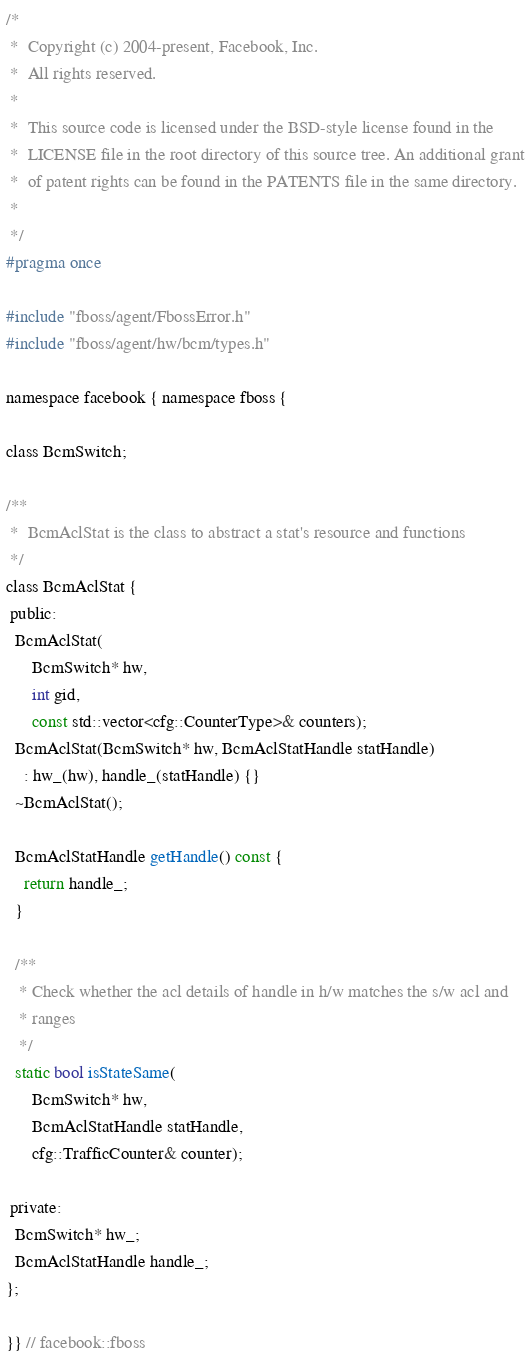<code> <loc_0><loc_0><loc_500><loc_500><_C_>/*
 *  Copyright (c) 2004-present, Facebook, Inc.
 *  All rights reserved.
 *
 *  This source code is licensed under the BSD-style license found in the
 *  LICENSE file in the root directory of this source tree. An additional grant
 *  of patent rights can be found in the PATENTS file in the same directory.
 *
 */
#pragma once

#include "fboss/agent/FbossError.h"
#include "fboss/agent/hw/bcm/types.h"

namespace facebook { namespace fboss {

class BcmSwitch;

/**
 *  BcmAclStat is the class to abstract a stat's resource and functions
 */
class BcmAclStat {
 public:
  BcmAclStat(
      BcmSwitch* hw,
      int gid,
      const std::vector<cfg::CounterType>& counters);
  BcmAclStat(BcmSwitch* hw, BcmAclStatHandle statHandle)
    : hw_(hw), handle_(statHandle) {}
  ~BcmAclStat();

  BcmAclStatHandle getHandle() const {
    return handle_;
  }

  /**
   * Check whether the acl details of handle in h/w matches the s/w acl and
   * ranges
   */
  static bool isStateSame(
      BcmSwitch* hw,
      BcmAclStatHandle statHandle,
      cfg::TrafficCounter& counter);

 private:
  BcmSwitch* hw_;
  BcmAclStatHandle handle_;
};

}} // facebook::fboss
</code> 